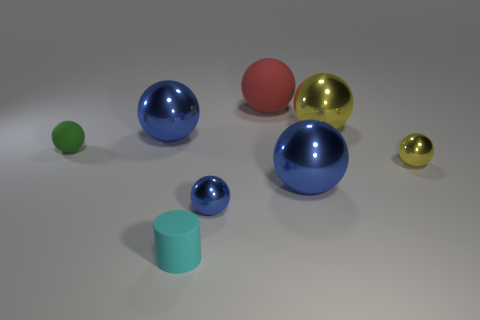There is a thing that is left of the tiny blue metal object and in front of the small rubber ball; what shape is it?
Your answer should be compact. Cylinder. Are there the same number of big yellow metal things left of the small cyan matte thing and balls that are right of the small yellow shiny object?
Provide a short and direct response. Yes. What number of things are rubber cylinders or blue balls?
Make the answer very short. 4. What is the color of the rubber sphere that is the same size as the cyan rubber thing?
Provide a short and direct response. Green. What number of objects are either blue metallic objects that are in front of the small green rubber sphere or matte things that are on the right side of the cylinder?
Your response must be concise. 3. Are there the same number of big blue things that are on the left side of the red matte thing and small yellow metallic objects?
Offer a terse response. Yes. Is the size of the yellow object in front of the large yellow sphere the same as the object that is behind the big yellow shiny thing?
Provide a succinct answer. No. What number of other things are the same size as the red matte object?
Keep it short and to the point. 3. There is a big blue object that is in front of the large metallic object left of the matte cylinder; are there any big rubber balls that are in front of it?
Keep it short and to the point. No. What size is the matte ball to the right of the cyan rubber thing?
Provide a short and direct response. Large. 